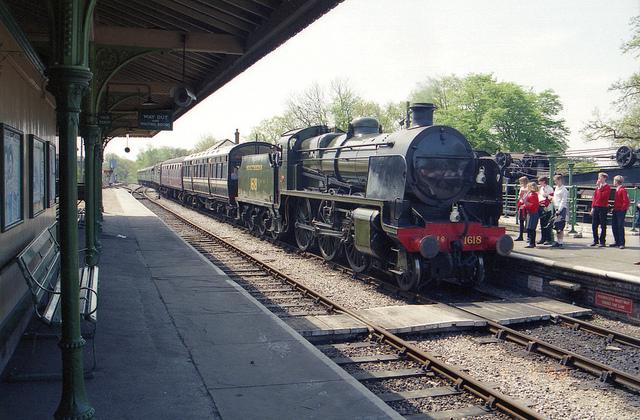Could the train be electric?
Write a very short answer. No. Are there people?
Answer briefly. Yes. What are on?
Give a very brief answer. Train. Is this a freight train?
Keep it brief. No. How many people are on the right?
Quick response, please. 6. Is the left side platform empty?
Answer briefly. Yes. 